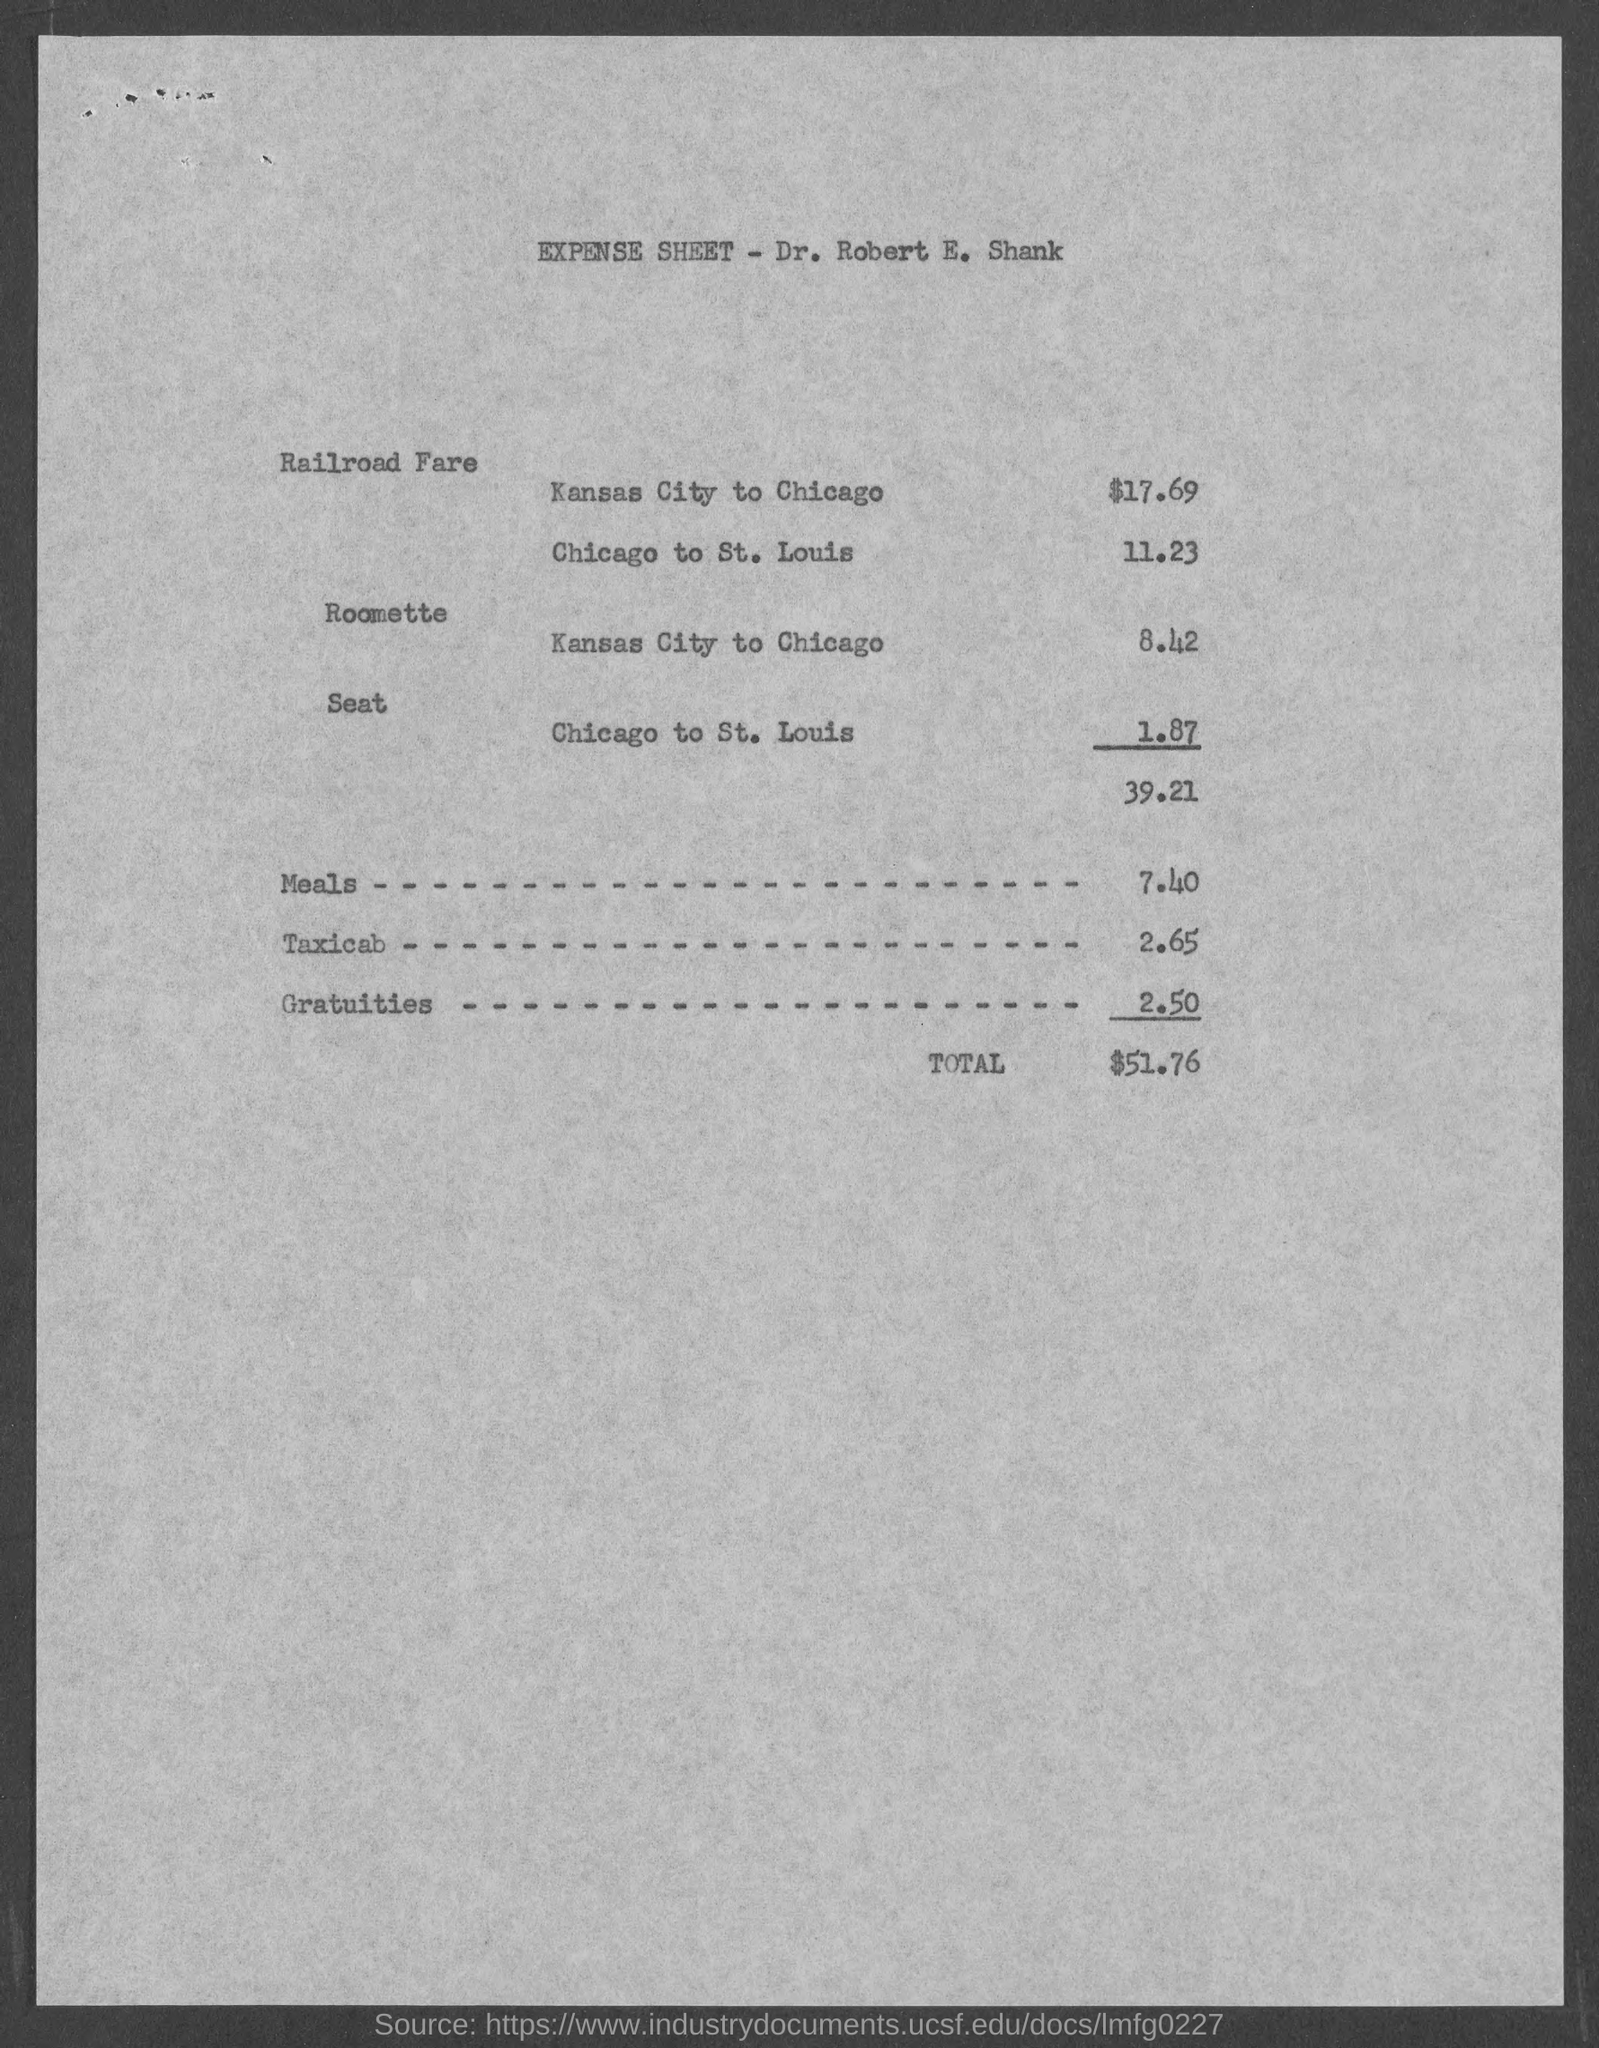Give some essential details in this illustration. The seat fare for traveling from Chicago to St. Louis is $1.87. The cost of meals is 7.40, according to the given amount. The cost of the railroad journey from Kansas City to Chicago is $17.69. The fare for traveling from Chicago to St. Louis by railroad is $11.23. The amount for a taxi cab is 2.65 dollars. 